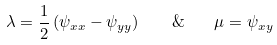<formula> <loc_0><loc_0><loc_500><loc_500>\lambda = \frac { 1 } { 2 } \left ( \psi _ { x x } - \psi _ { y y } \right ) \quad \& \quad \mu = \psi _ { x y }</formula> 